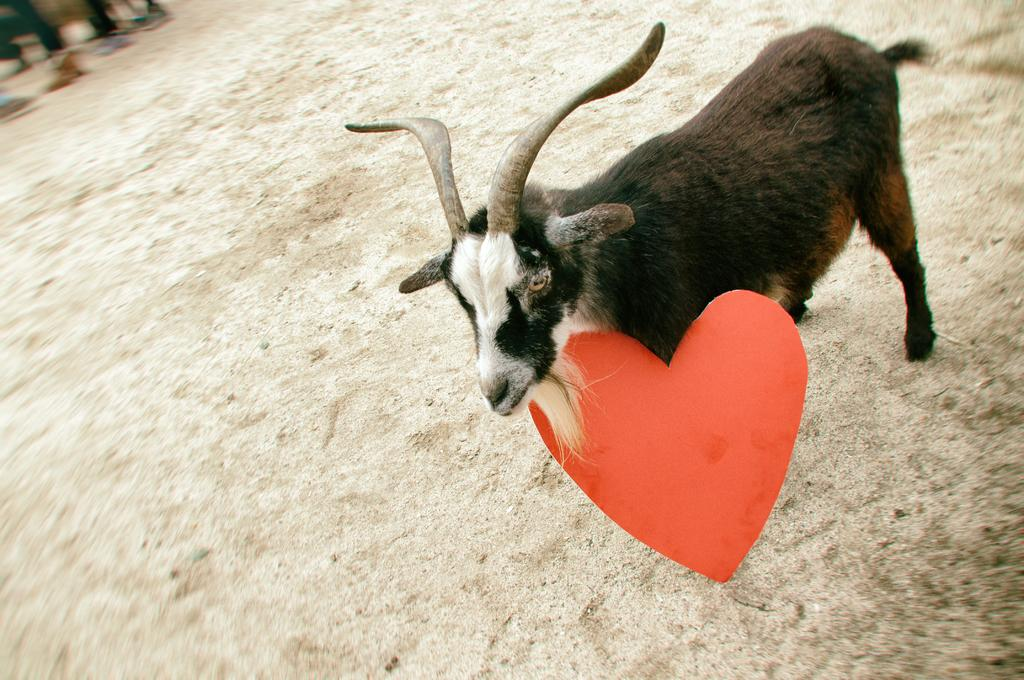What animal is present in the image? There is a goat in the image. What feature stands out on the goat? The goat has big horns. Where is the goat located in the image? The goat is standing on the ground at the right side of the image. What object is below the goat's neck? There is a red heart-shaped paper below the goat's neck. Reasoning: Let' Let's think step by step in order to produce the conversation. We start by identifying the main subject in the image, which is the goat. Then, we describe the goat's notable features, such as its big horns. Next, we specify the goat's location in the image, which is standing on the ground at the right side. Finally, we mention the red heart-shaped paper below the goat's neck, which is an additional detail provided in the facts. Absurd Question/Answer: What type of wheel can be seen attached to the goat's leg in the image? There is no wheel present in the image, and the goat's legs are not attached to any wheel. 